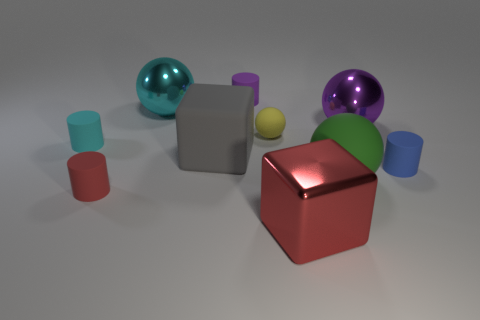What shape is the large gray thing that is the same material as the small yellow sphere?
Give a very brief answer. Cube. What number of purple rubber things have the same shape as the purple metal thing?
Provide a succinct answer. 0. Is the shape of the cyan thing that is on the right side of the tiny red rubber cylinder the same as the purple thing right of the large green matte ball?
Ensure brevity in your answer.  Yes. What number of objects are either big cyan things or purple objects that are behind the large cyan sphere?
Your answer should be very brief. 2. What shape is the thing that is the same color as the shiny block?
Your answer should be compact. Cylinder. How many cylinders have the same size as the yellow sphere?
Provide a succinct answer. 4. What number of purple objects are either tiny metal objects or shiny blocks?
Keep it short and to the point. 0. What shape is the purple thing that is in front of the rubber cylinder that is behind the big cyan metallic sphere?
Keep it short and to the point. Sphere. The yellow object that is the same size as the red rubber thing is what shape?
Make the answer very short. Sphere. Is there a small rubber cylinder that has the same color as the metallic block?
Provide a succinct answer. Yes. 